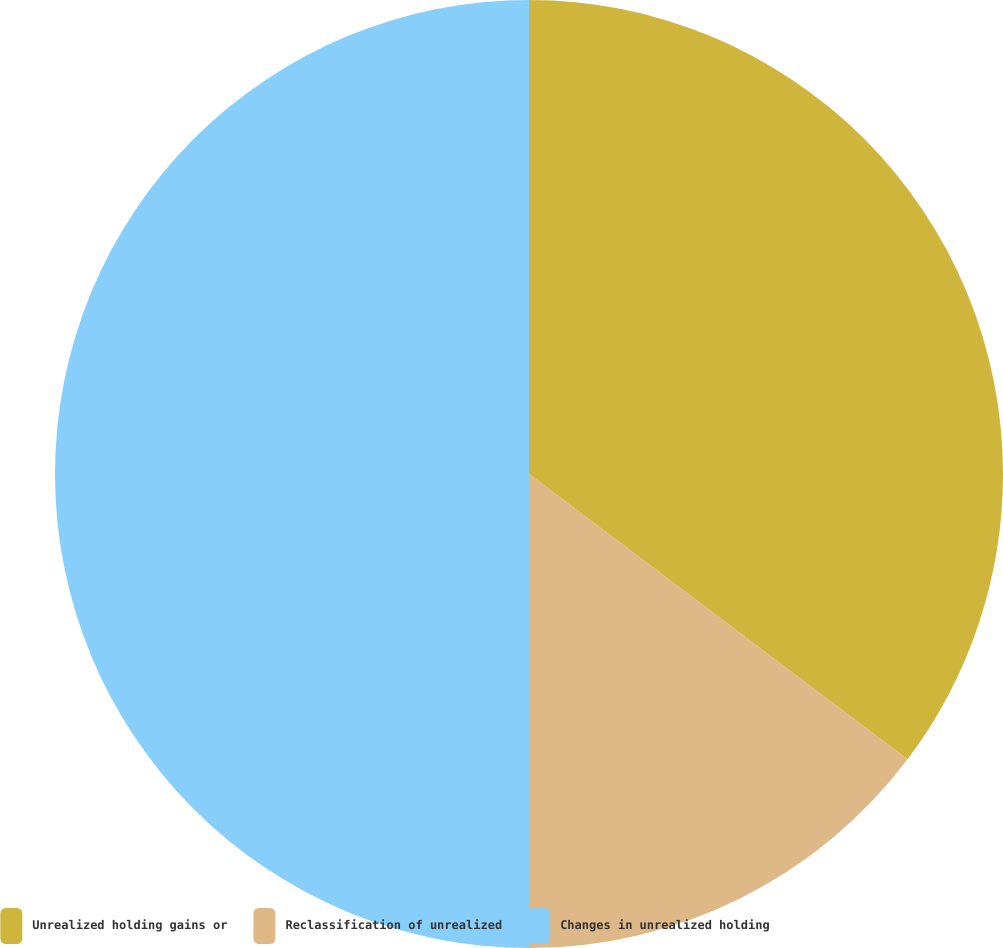Convert chart. <chart><loc_0><loc_0><loc_500><loc_500><pie_chart><fcel>Unrealized holding gains or<fcel>Reclassification of unrealized<fcel>Changes in unrealized holding<nl><fcel>35.28%<fcel>14.72%<fcel>50.0%<nl></chart> 